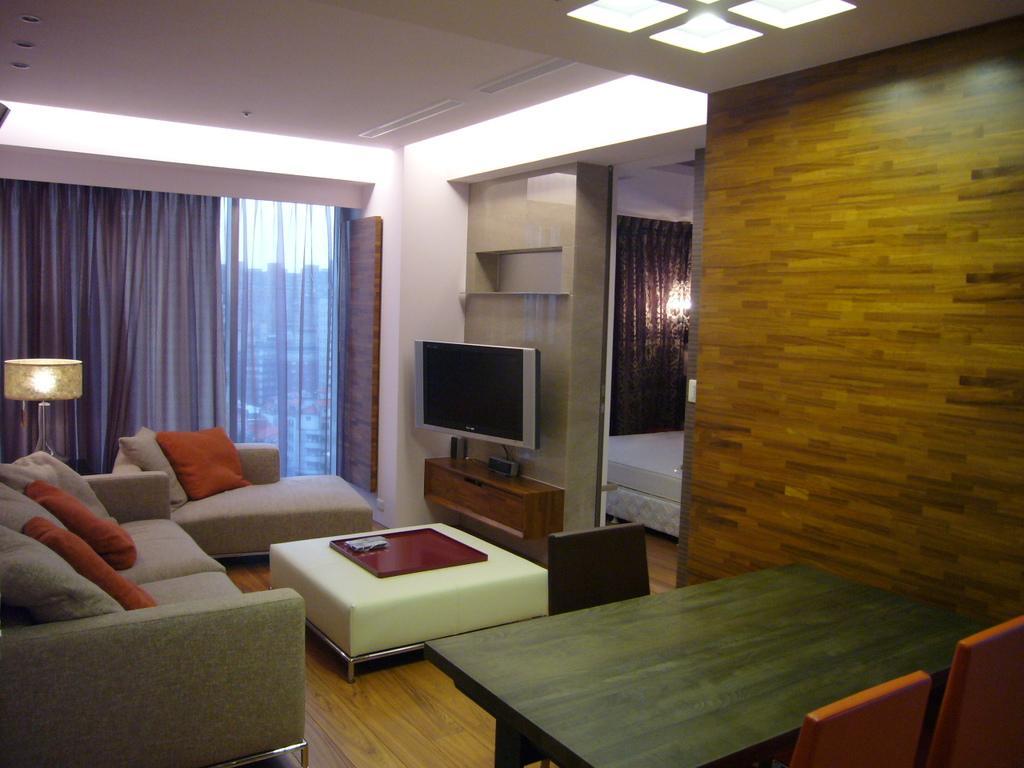Please provide a concise description of this image. This picture is clicked inside the room. Here, we see dining table and chairs in orange color. Beside that, we see a wall. On the left side, we see sofa on which cushions are placed. Beside that, we see a lamp. Behind the lamp, we see a window and a curtain in blue color. In the middle of the picture, we see a television is placed on the cupboard. Beside that, we see a bed. At the top of the picture, we see the ceiling of the room. 